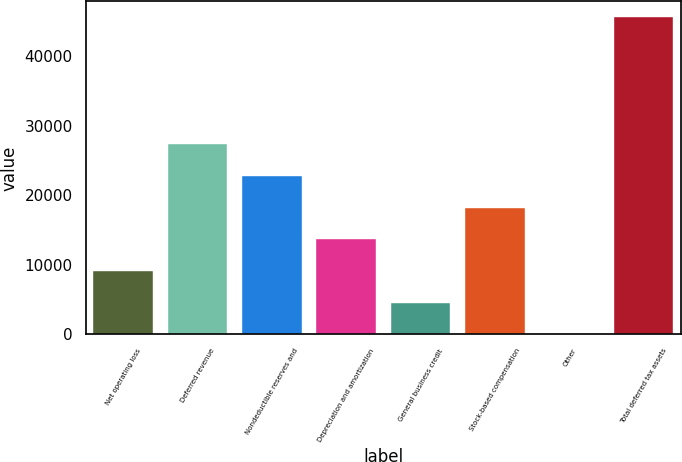Convert chart. <chart><loc_0><loc_0><loc_500><loc_500><bar_chart><fcel>Net operating loss<fcel>Deferred revenue<fcel>Nondeductible reserves and<fcel>Depreciation and amortization<fcel>General business credit<fcel>Stock-based compensation<fcel>Other<fcel>Total deferred tax assets<nl><fcel>9137<fcel>27369<fcel>22811<fcel>13695<fcel>4579<fcel>18253<fcel>21<fcel>45601<nl></chart> 